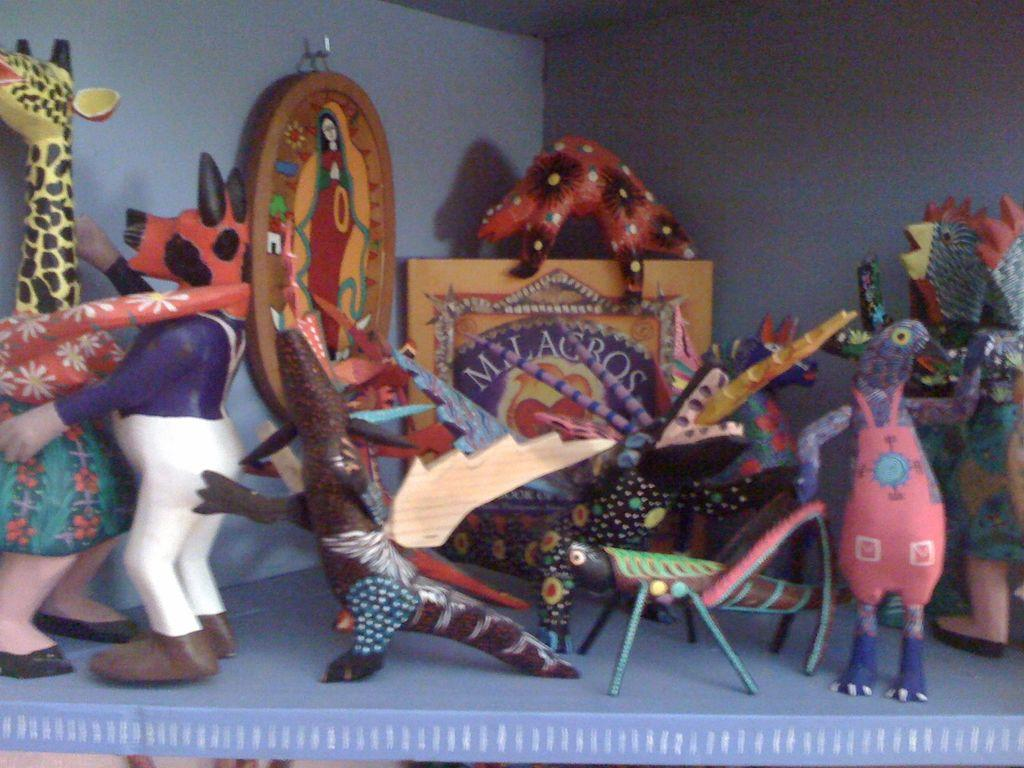What can be seen in the image? There are many toys in the image. What is the color of the surface on which the toys are placed? The toys are placed on a blue surface. Is there anything else visible on the wall in the image? Yes, there is a frame hanging on the wall in the image. Can you see any teeth biting into the toys in the image? No, there are no teeth or biting visible in the image. 